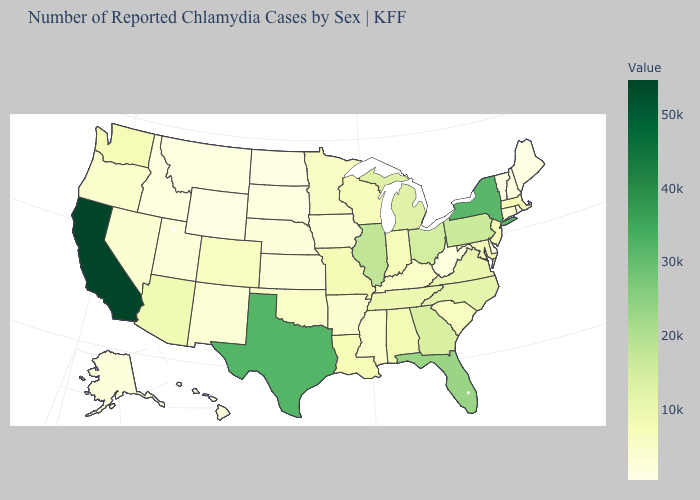Does the map have missing data?
Write a very short answer. No. Which states have the lowest value in the USA?
Quick response, please. Vermont. Does Massachusetts have a higher value than Rhode Island?
Quick response, please. Yes. Does Indiana have the lowest value in the USA?
Give a very brief answer. No. Does Vermont have the lowest value in the USA?
Write a very short answer. Yes. 